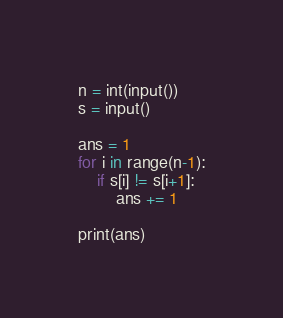<code> <loc_0><loc_0><loc_500><loc_500><_Python_>n = int(input())
s = input()

ans = 1
for i in range(n-1):
    if s[i] != s[i+1]:
        ans += 1

print(ans)</code> 